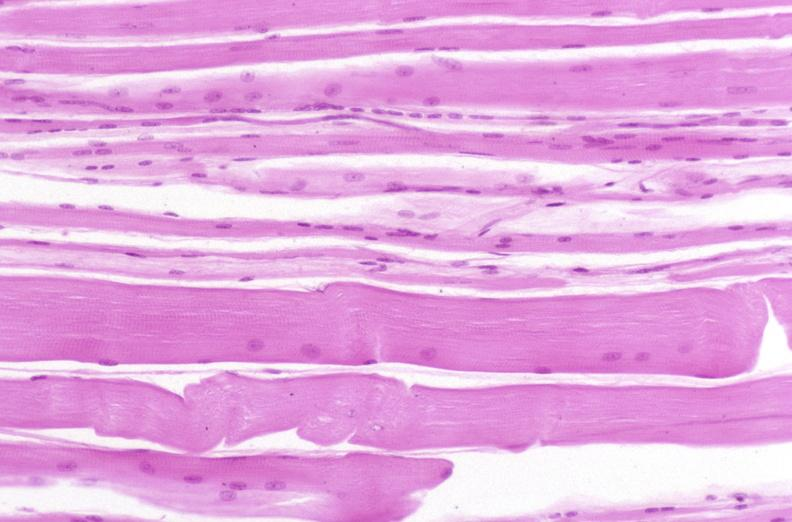does hypospadias show skeletal muscle, atrophy due to immobilization cast?
Answer the question using a single word or phrase. No 